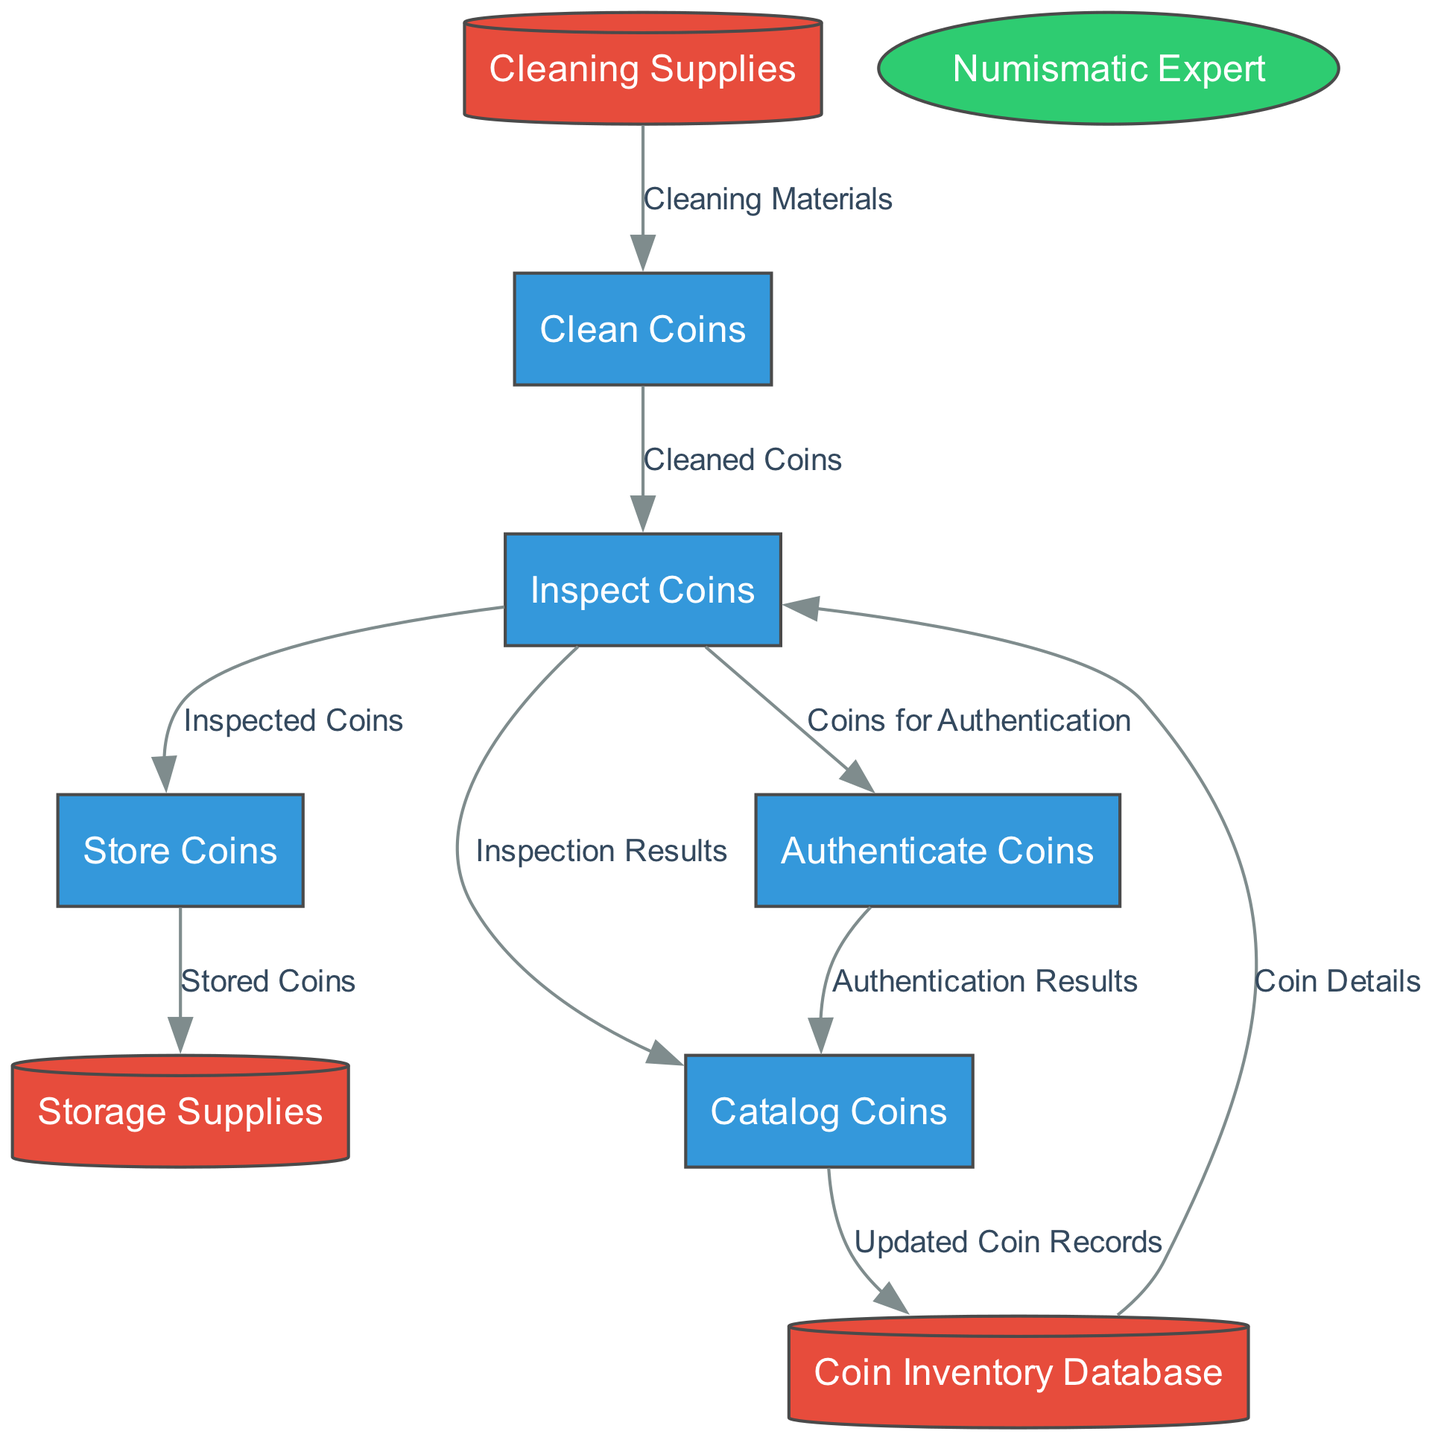What's the name of the process that follows inspecting coins? The diagram shows a flow from "Inspect Coins" to "Store Coins," indicating that after coins are inspected, they are then stored.
Answer: Store Coins How many processes are depicted in this diagram? By counting the number of processes listed in the diagram, we see five distinct processes: "Inspect Coins," "Clean Coins," "Catalog Coins," "Store Coins," and "Authenticate Coins."
Answer: Five What data is used to clean the coins? The flow from "Cleaning Supplies" to "Clean Coins" indicates that "Cleaning Materials" are the required data for the cleaning process.
Answer: Cleaning Materials What relationship is there between "Authenticate Coins" and "Catalog Coins"? The flow from "Authenticate Coins" to "Catalog Coins" suggests that the results from the authentication are recorded in the catalog process, indicating a dependency of cataloging on authentication.
Answer: Authentication Results Which data store contains detailed records of coins? The "Coin Inventory Database" is specifically mentioned in the diagram as holding detailed records of all the coins in the collection.
Answer: Coin Inventory Database What type of expert verifies coin authenticity? The diagram identifies the external entity responsible for authenticity verification as a "Numismatic Expert."
Answer: Numismatic Expert What is the purpose of storing coins in a climate-controlled environment? The description for the process "Store Coins" mentions storing coins in a protective manner to ensure their preservation, which includes a climate-controlled environment to prevent deterioration.
Answer: To preserve coin quality What comes after "Clean Coins" in the workflow? The diagram indicates that "Clean Coins" sends "Cleaned Coins" back to "Inspect Coins," meaning the workflow re-evaluates the cleaned coins.
Answer: Inspect Coins What is the flow of information from the "Inspect Coins" process? The "Inspect Coins" process communicates to several others, specifically sending "Inspected Coins" to "Store Coins," "Inspection Results" to "Catalog Coins," and "Coins for Authentication" to "Authenticate Coins".
Answer: Several processes 